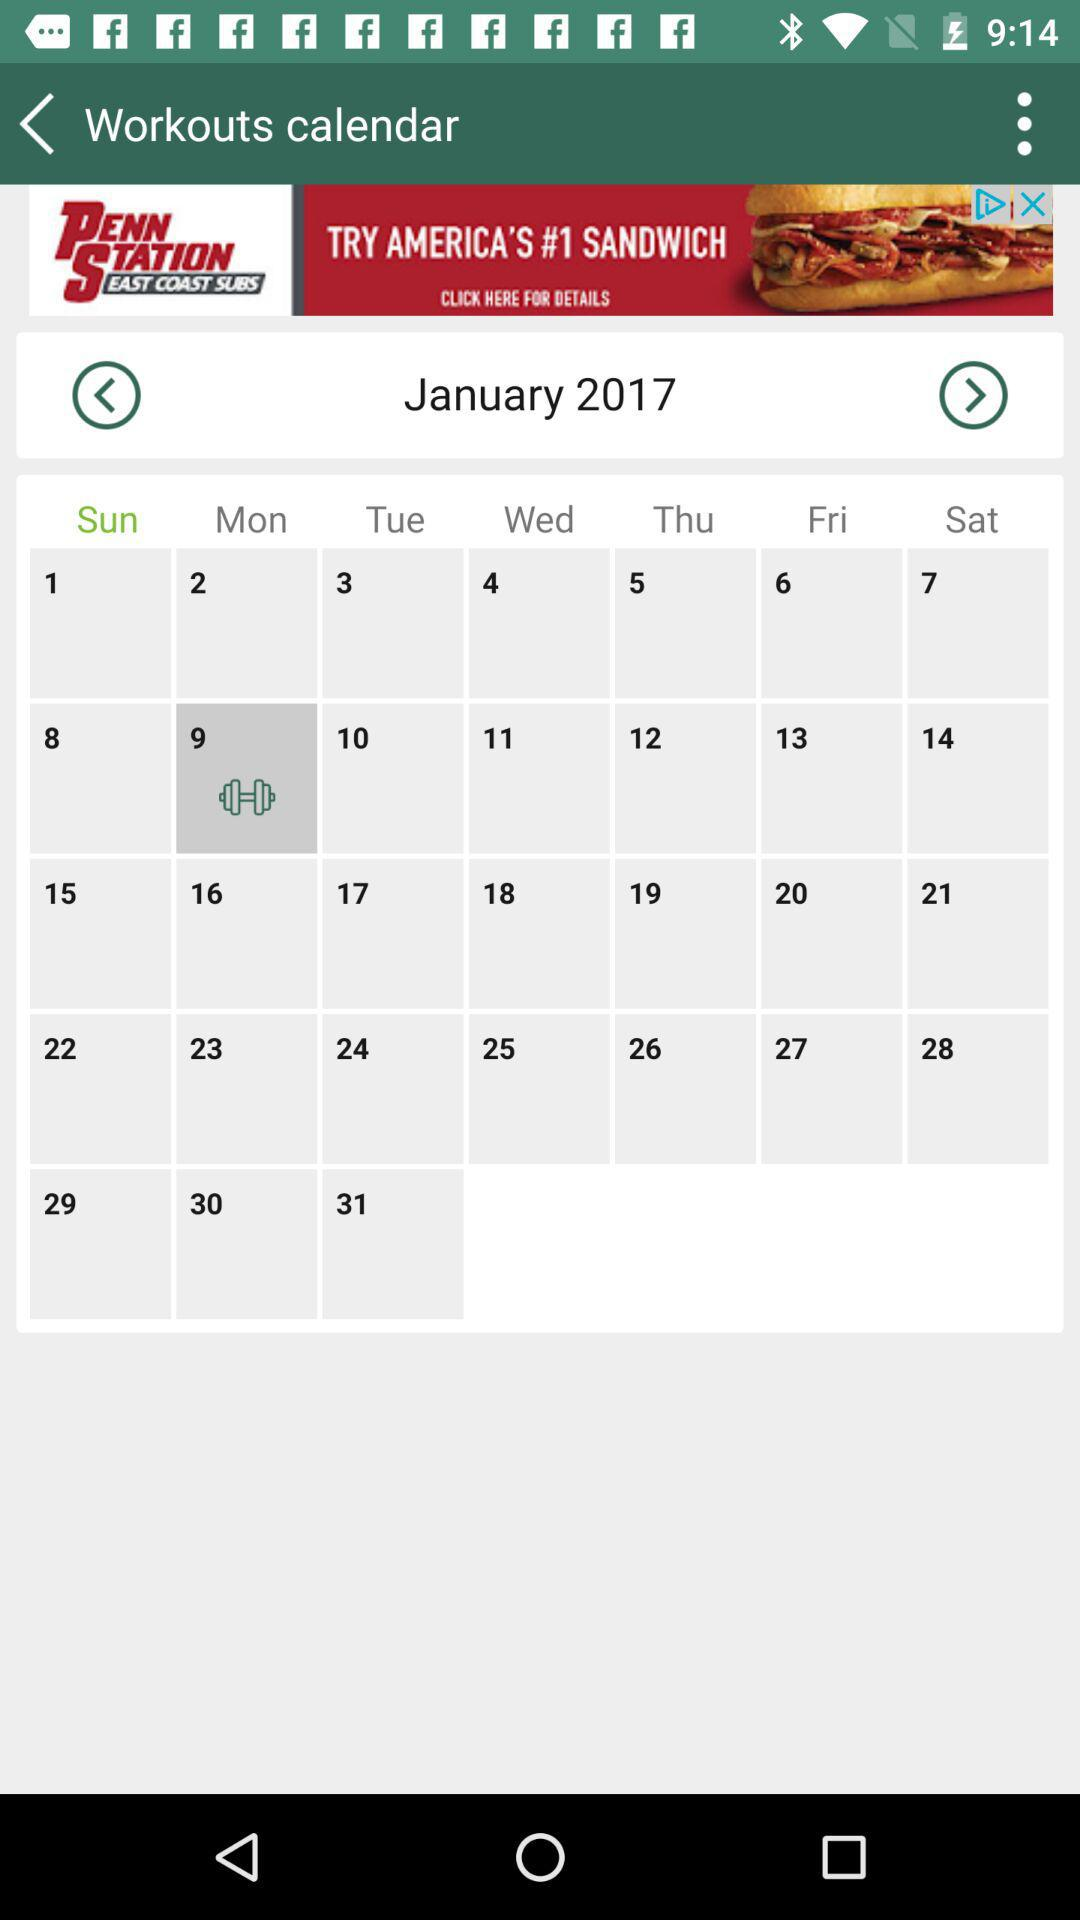What date is scheduled for a workout? The date is 9. 